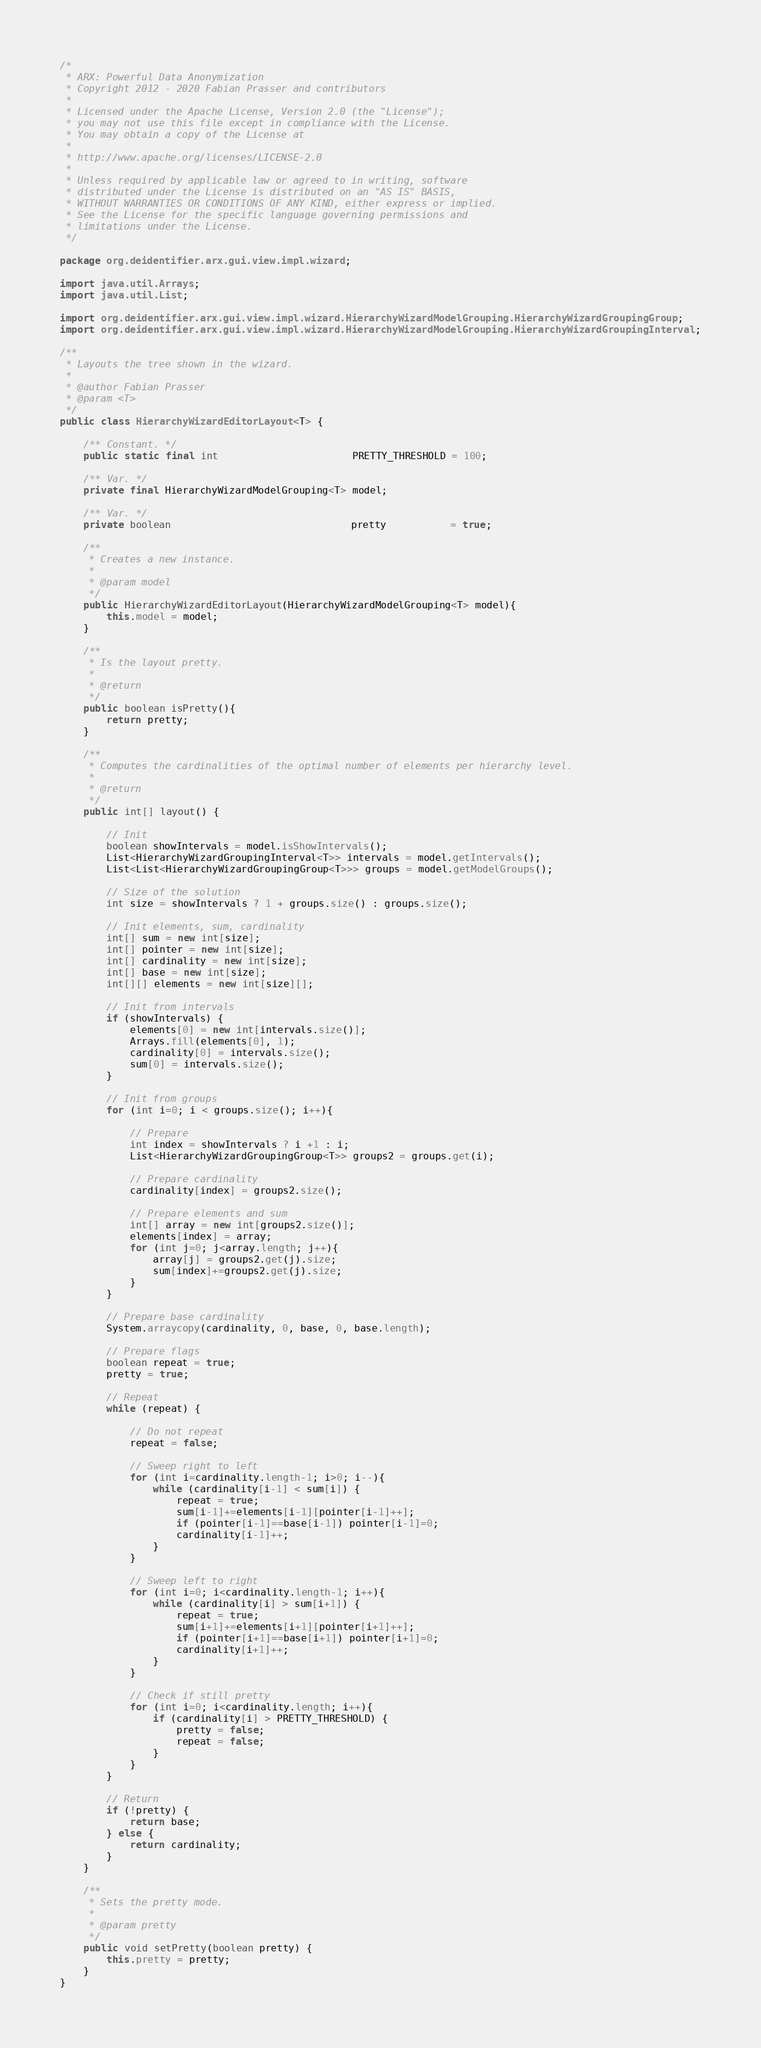Convert code to text. <code><loc_0><loc_0><loc_500><loc_500><_Java_>/*
 * ARX: Powerful Data Anonymization
 * Copyright 2012 - 2020 Fabian Prasser and contributors
 * 
 * Licensed under the Apache License, Version 2.0 (the "License");
 * you may not use this file except in compliance with the License.
 * You may obtain a copy of the License at
 * 
 * http://www.apache.org/licenses/LICENSE-2.0
 * 
 * Unless required by applicable law or agreed to in writing, software
 * distributed under the License is distributed on an "AS IS" BASIS,
 * WITHOUT WARRANTIES OR CONDITIONS OF ANY KIND, either express or implied.
 * See the License for the specific language governing permissions and
 * limitations under the License.
 */

package org.deidentifier.arx.gui.view.impl.wizard;

import java.util.Arrays;
import java.util.List;

import org.deidentifier.arx.gui.view.impl.wizard.HierarchyWizardModelGrouping.HierarchyWizardGroupingGroup;
import org.deidentifier.arx.gui.view.impl.wizard.HierarchyWizardModelGrouping.HierarchyWizardGroupingInterval;

/**
 * Layouts the tree shown in the wizard.
 *
 * @author Fabian Prasser
 * @param <T>
 */
public class HierarchyWizardEditorLayout<T> {

    /** Constant. */
    public static final int                       PRETTY_THRESHOLD = 100;

    /** Var. */
    private final HierarchyWizardModelGrouping<T> model;
    
    /** Var. */
    private boolean                               pretty           = true;

    /**
     * Creates a new instance.
     *
     * @param model
     */
    public HierarchyWizardEditorLayout(HierarchyWizardModelGrouping<T> model){
        this.model = model;
    }

    /**
     * Is the layout pretty.
     *
     * @return
     */
    public boolean isPretty(){
        return pretty;
    }
    
    /**
     * Computes the cardinalities of the optimal number of elements per hierarchy level.
     *
     * @return
     */
    public int[] layout() {
        
        // Init
        boolean showIntervals = model.isShowIntervals();
        List<HierarchyWizardGroupingInterval<T>> intervals = model.getIntervals();
        List<List<HierarchyWizardGroupingGroup<T>>> groups = model.getModelGroups();

        // Size of the solution
        int size = showIntervals ? 1 + groups.size() : groups.size();
        
        // Init elements, sum, cardinality
        int[] sum = new int[size];
        int[] pointer = new int[size];
        int[] cardinality = new int[size];
        int[] base = new int[size];
        int[][] elements = new int[size][];
        
        // Init from intervals
        if (showIntervals) {
            elements[0] = new int[intervals.size()];
            Arrays.fill(elements[0], 1);
            cardinality[0] = intervals.size();
            sum[0] = intervals.size();
        } 
        
        // Init from groups
        for (int i=0; i < groups.size(); i++){
            
            // Prepare
            int index = showIntervals ? i +1 : i;
            List<HierarchyWizardGroupingGroup<T>> groups2 = groups.get(i);
            
            // Prepare cardinality
            cardinality[index] = groups2.size();
            
            // Prepare elements and sum
            int[] array = new int[groups2.size()];
            elements[index] = array;
            for (int j=0; j<array.length; j++){
                array[j] = groups2.get(j).size;
                sum[index]+=groups2.get(j).size;
            }
        }
        
        // Prepare base cardinality
        System.arraycopy(cardinality, 0, base, 0, base.length);
        
        // Prepare flags
        boolean repeat = true;
        pretty = true;
        
        // Repeat
        while (repeat) {
            
            // Do not repeat
            repeat = false;
            
            // Sweep right to left
            for (int i=cardinality.length-1; i>0; i--){
                while (cardinality[i-1] < sum[i]) {
                    repeat = true;
                    sum[i-1]+=elements[i-1][pointer[i-1]++];
                    if (pointer[i-1]==base[i-1]) pointer[i-1]=0;
                    cardinality[i-1]++;
                }
            }
            
            // Sweep left to right
            for (int i=0; i<cardinality.length-1; i++){
                while (cardinality[i] > sum[i+1]) {
                    repeat = true;
                    sum[i+1]+=elements[i+1][pointer[i+1]++];
                    if (pointer[i+1]==base[i+1]) pointer[i+1]=0;
                    cardinality[i+1]++;
                }
            }
            
            // Check if still pretty
            for (int i=0; i<cardinality.length; i++){
                if (cardinality[i] > PRETTY_THRESHOLD) {
                    pretty = false;
                    repeat = false;
                }
            }
        }
        
        // Return
        if (!pretty) {
            return base;
        } else {
            return cardinality;
        }
    }

    /**
     * Sets the pretty mode.
     *
     * @param pretty
     */
    public void setPretty(boolean pretty) {
        this.pretty = pretty;
    }
}
</code> 